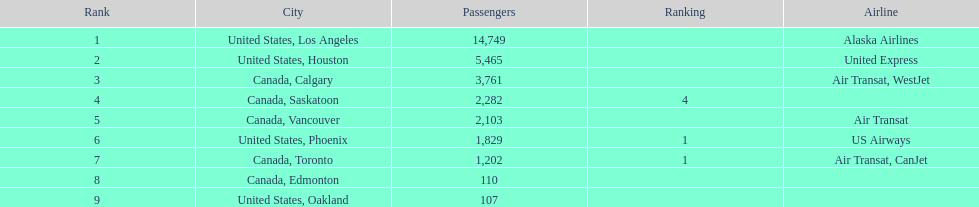Can you give me this table as a dict? {'header': ['Rank', 'City', 'Passengers', 'Ranking', 'Airline'], 'rows': [['1', 'United States, Los Angeles', '14,749', '', 'Alaska Airlines'], ['2', 'United States, Houston', '5,465', '', 'United Express'], ['3', 'Canada, Calgary', '3,761', '', 'Air Transat, WestJet'], ['4', 'Canada, Saskatoon', '2,282', '4', ''], ['5', 'Canada, Vancouver', '2,103', '', 'Air Transat'], ['6', 'United States, Phoenix', '1,829', '1', 'US Airways'], ['7', 'Canada, Toronto', '1,202', '1', 'Air Transat, CanJet'], ['8', 'Canada, Edmonton', '110', '', ''], ['9', 'United States, Oakland', '107', '', '']]} How many additional passengers traveled to los angeles compared to saskatoon from manzanillo airport in 2013? 12,467. 